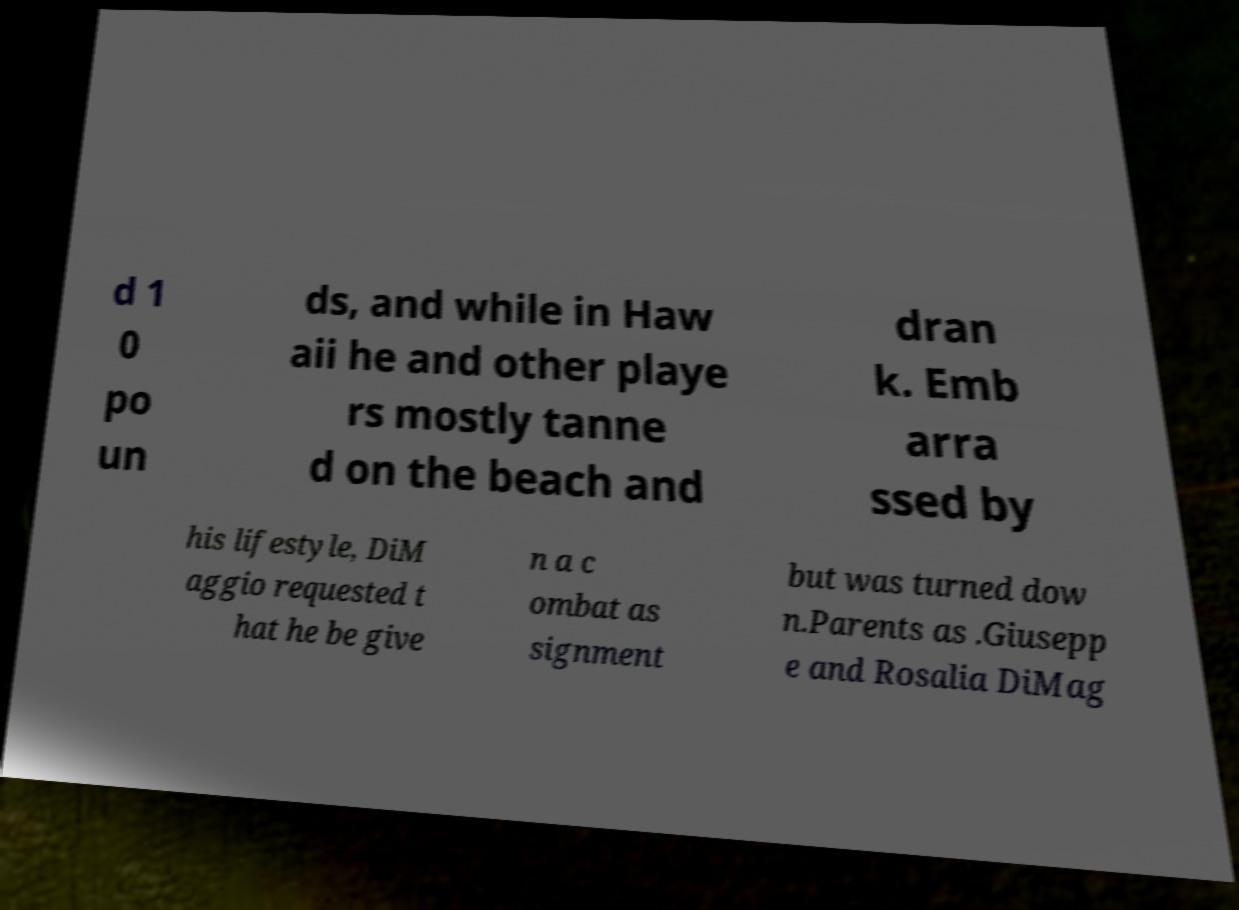What messages or text are displayed in this image? I need them in a readable, typed format. d 1 0 po un ds, and while in Haw aii he and other playe rs mostly tanne d on the beach and dran k. Emb arra ssed by his lifestyle, DiM aggio requested t hat he be give n a c ombat as signment but was turned dow n.Parents as .Giusepp e and Rosalia DiMag 